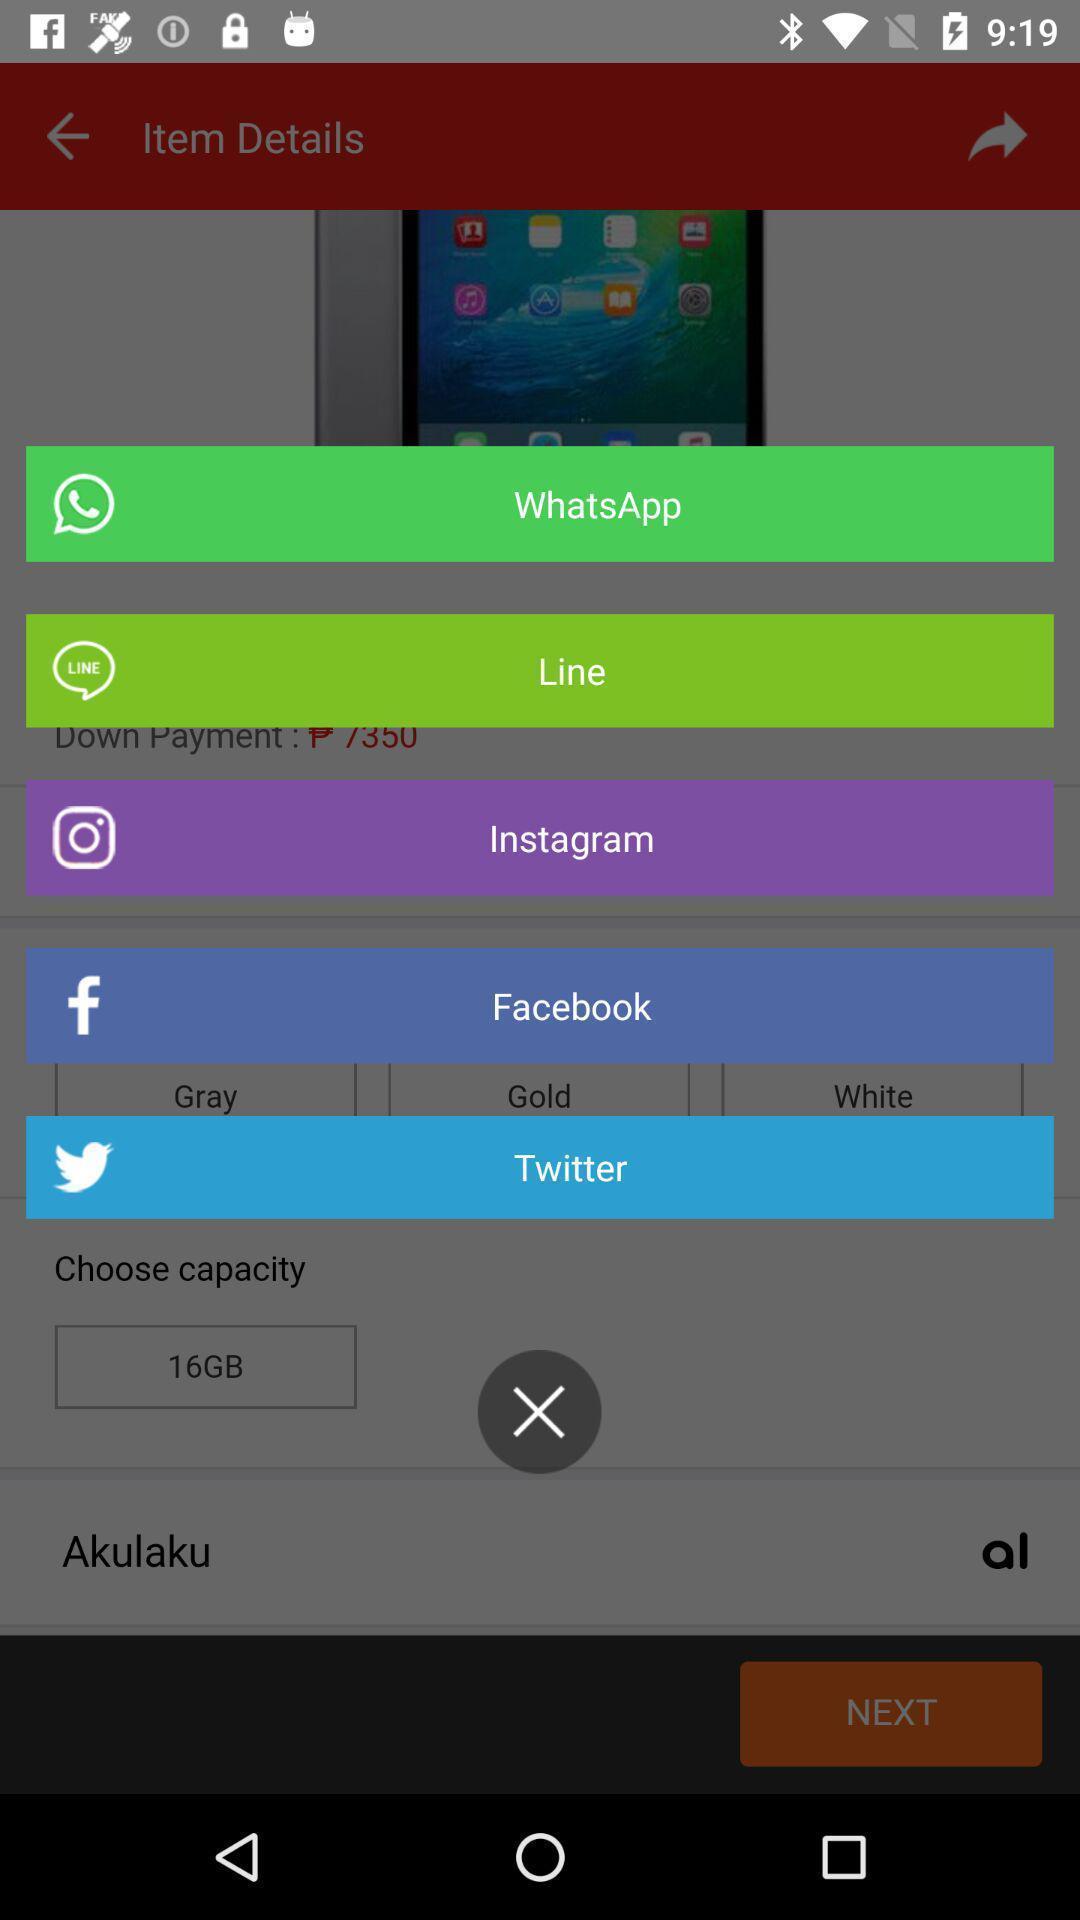Describe the visual elements of this screenshot. Pop up showing list of social applications. 